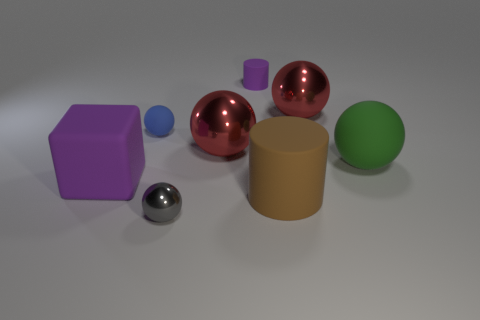Subtract 1 spheres. How many spheres are left? 4 Subtract all green matte balls. How many balls are left? 4 Subtract all green balls. How many balls are left? 4 Subtract all purple balls. Subtract all red cylinders. How many balls are left? 5 Add 1 purple cubes. How many objects exist? 9 Subtract all blocks. How many objects are left? 7 Subtract all large blue metal cylinders. Subtract all small blue rubber things. How many objects are left? 7 Add 4 big green rubber objects. How many big green rubber objects are left? 5 Add 2 tiny metallic objects. How many tiny metallic objects exist? 3 Subtract 2 red balls. How many objects are left? 6 